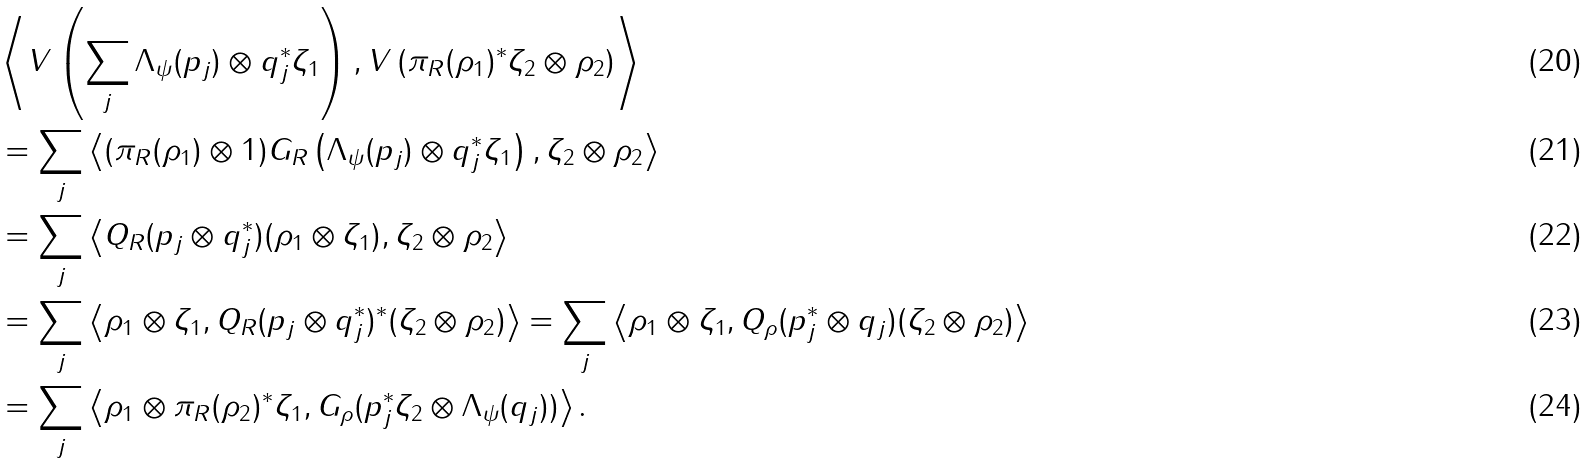<formula> <loc_0><loc_0><loc_500><loc_500>& \left \langle V \left ( \sum _ { j } \Lambda _ { \psi } ( p _ { j } ) \otimes q _ { j } ^ { * } \zeta _ { 1 } \right ) , V \left ( \pi _ { R } ( \rho _ { 1 } ) ^ { * } \zeta _ { 2 } \otimes \rho _ { 2 } \right ) \right \rangle \\ & = \sum _ { j } \left \langle ( \pi _ { R } ( \rho _ { 1 } ) \otimes 1 ) G _ { R } \left ( \Lambda _ { \psi } ( p _ { j } ) \otimes q _ { j } ^ { * } \zeta _ { 1 } \right ) , \zeta _ { 2 } \otimes \rho _ { 2 } \right \rangle \\ & = \sum _ { j } \left \langle Q _ { R } ( p _ { j } \otimes q _ { j } ^ { * } ) ( \rho _ { 1 } \otimes \zeta _ { 1 } ) , \zeta _ { 2 } \otimes \rho _ { 2 } \right \rangle \\ & = \sum _ { j } \left \langle \rho _ { 1 } \otimes \zeta _ { 1 } , Q _ { R } ( p _ { j } \otimes q _ { j } ^ { * } ) ^ { * } ( \zeta _ { 2 } \otimes \rho _ { 2 } ) \right \rangle = \sum _ { j } \left \langle \rho _ { 1 } \otimes \zeta _ { 1 } , Q _ { \rho } ( p _ { j } ^ { * } \otimes q _ { j } ) ( \zeta _ { 2 } \otimes \rho _ { 2 } ) \right \rangle \\ & = \sum _ { j } \left \langle \rho _ { 1 } \otimes \pi _ { R } ( \rho _ { 2 } ) ^ { * } \zeta _ { 1 } , G _ { \rho } ( p _ { j } ^ { * } \zeta _ { 2 } \otimes \Lambda _ { \psi } ( q _ { j } ) ) \right \rangle .</formula> 